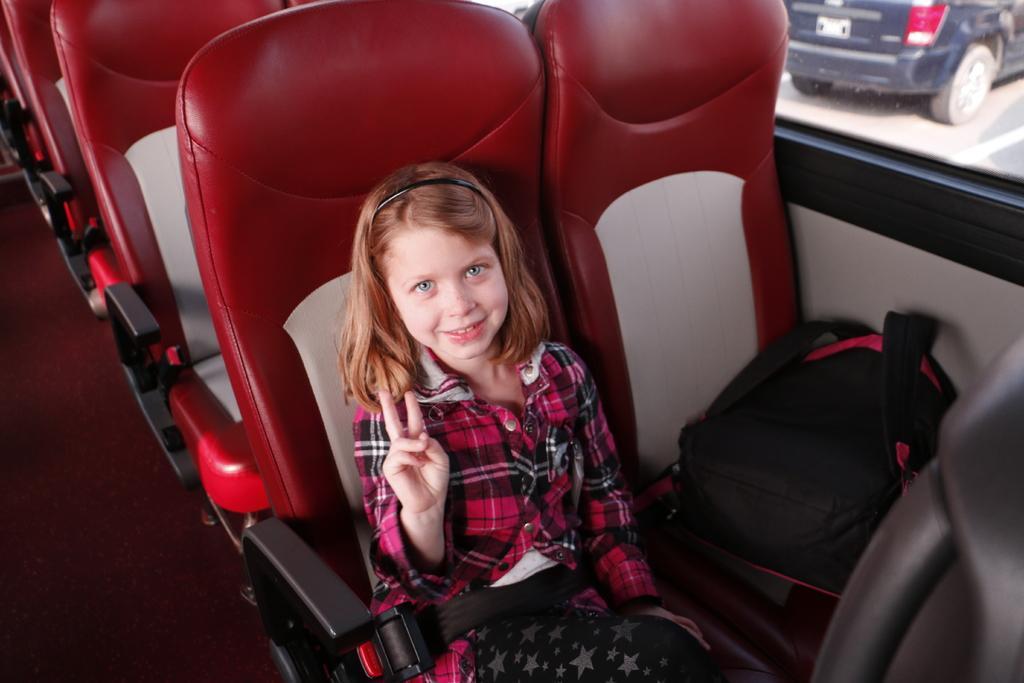In one or two sentences, can you explain what this image depicts? In this image, we can see a girl is sitting on a seat. She is watching and smiling. She wore a seatbelt. Here we can see backpack, some objects and seats. On the right side top corner, there is a glass window. Through the glass we can see vehicles and road. On the right side bottom, we can see black color object. Left side bottom of the image, we can see the walkway. 